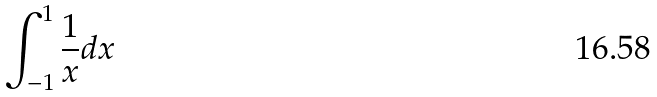Convert formula to latex. <formula><loc_0><loc_0><loc_500><loc_500>\int _ { - 1 } ^ { 1 } \frac { 1 } { x } d x</formula> 